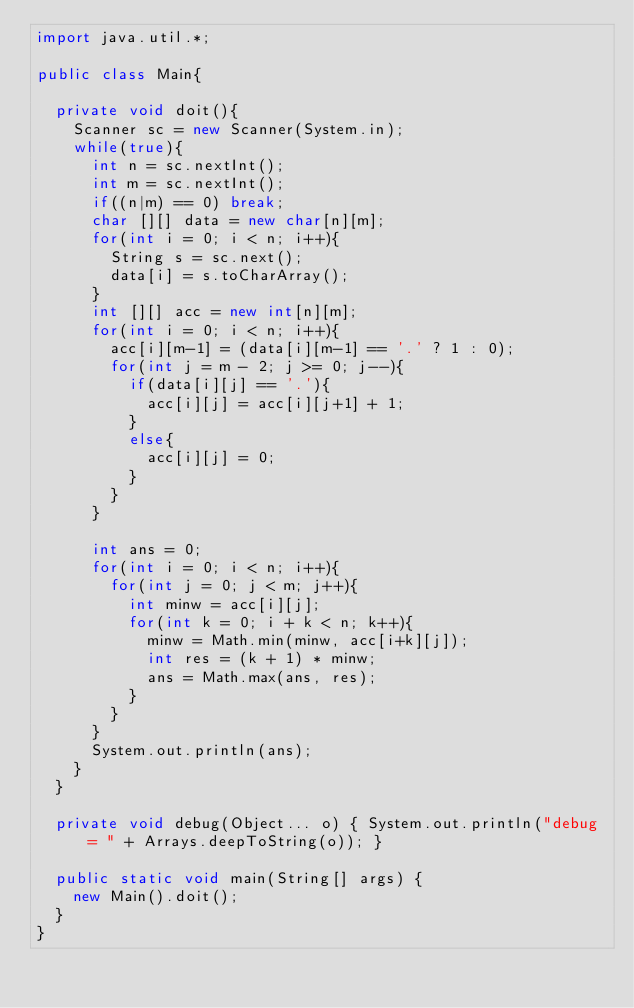Convert code to text. <code><loc_0><loc_0><loc_500><loc_500><_Java_>import java.util.*;

public class Main{
	
	private void doit(){
		Scanner sc = new Scanner(System.in);
		while(true){
			int n = sc.nextInt();
			int m = sc.nextInt();
			if((n|m) == 0) break;
			char [][] data = new char[n][m];
			for(int i = 0; i < n; i++){
				String s = sc.next();
				data[i] = s.toCharArray();
			}
			int [][] acc = new int[n][m];
			for(int i = 0; i < n; i++){
				acc[i][m-1] = (data[i][m-1] == '.' ? 1 : 0);
				for(int j = m - 2; j >= 0; j--){
					if(data[i][j] == '.'){
						acc[i][j] = acc[i][j+1] + 1;
					}
					else{
						acc[i][j] = 0;
					}
				}
			}
			
			int ans = 0;
			for(int i = 0; i < n; i++){
				for(int j = 0; j < m; j++){
					int minw = acc[i][j];
					for(int k = 0; i + k < n; k++){
						minw = Math.min(minw, acc[i+k][j]);
						int res = (k + 1) * minw;
						ans = Math.max(ans, res);
					}
				}
			}
			System.out.println(ans);
		}
	}

	private void debug(Object... o) { System.out.println("debug = " + Arrays.deepToString(o)); }

	public static void main(String[] args) {
		new Main().doit();
	}
}</code> 